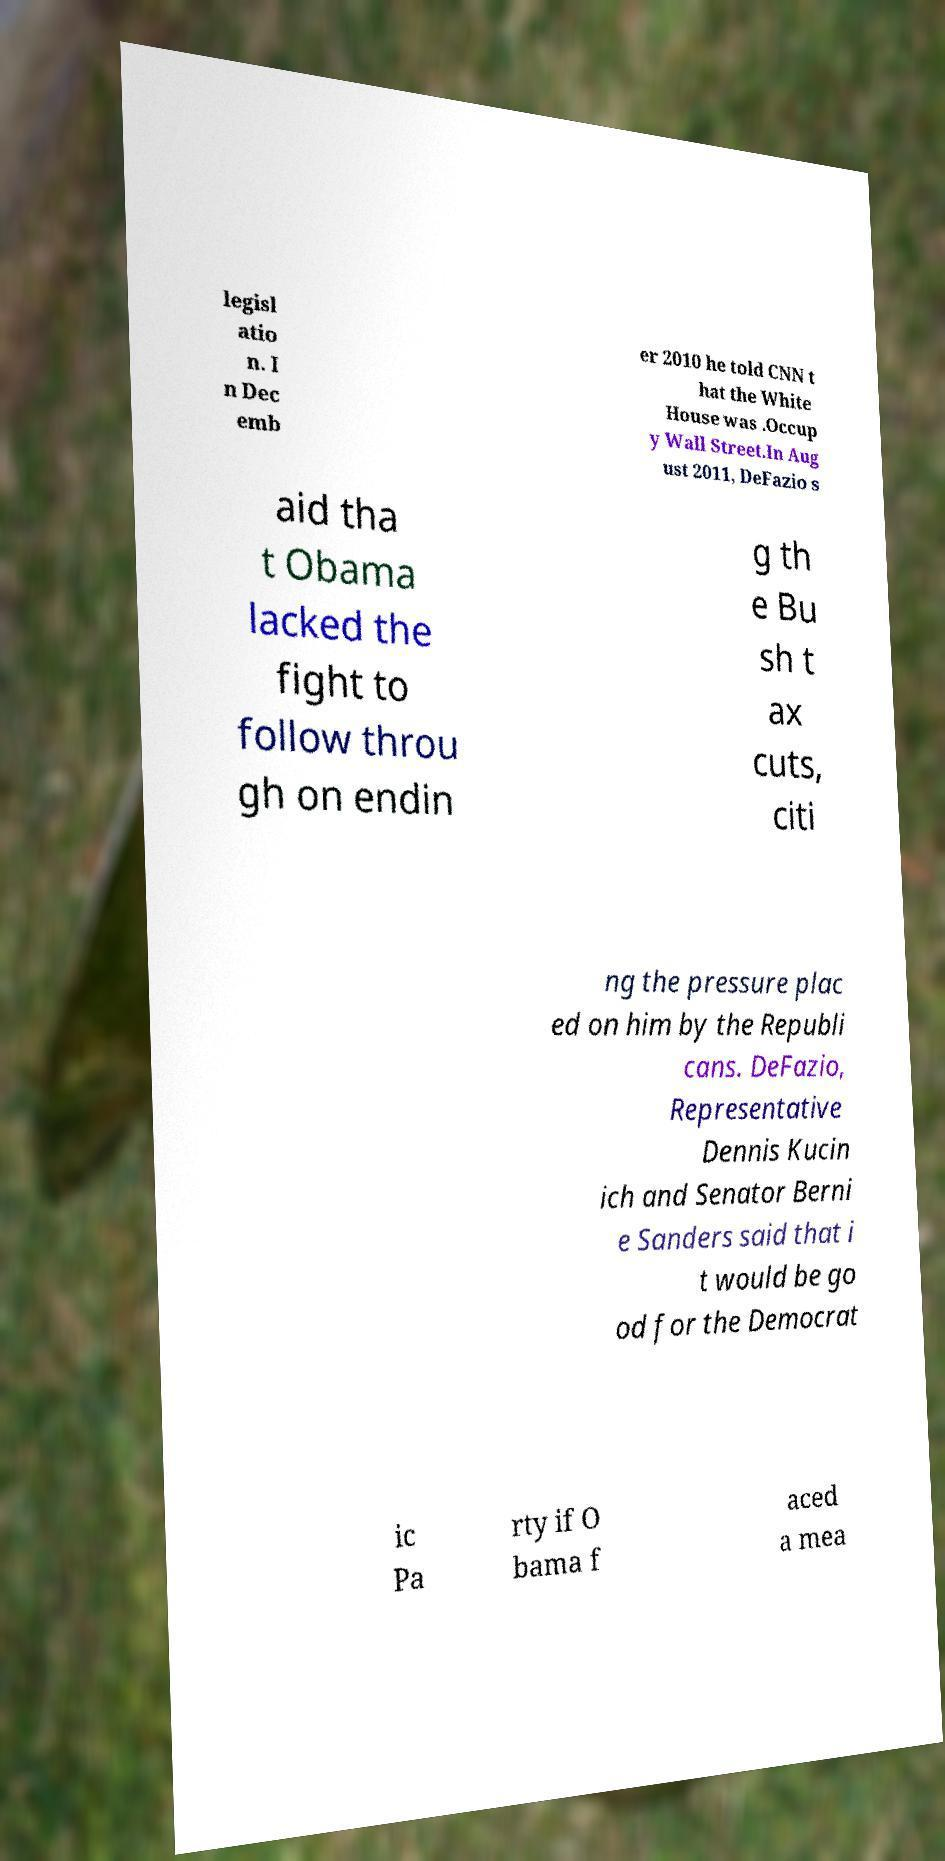For documentation purposes, I need the text within this image transcribed. Could you provide that? legisl atio n. I n Dec emb er 2010 he told CNN t hat the White House was .Occup y Wall Street.In Aug ust 2011, DeFazio s aid tha t Obama lacked the fight to follow throu gh on endin g th e Bu sh t ax cuts, citi ng the pressure plac ed on him by the Republi cans. DeFazio, Representative Dennis Kucin ich and Senator Berni e Sanders said that i t would be go od for the Democrat ic Pa rty if O bama f aced a mea 